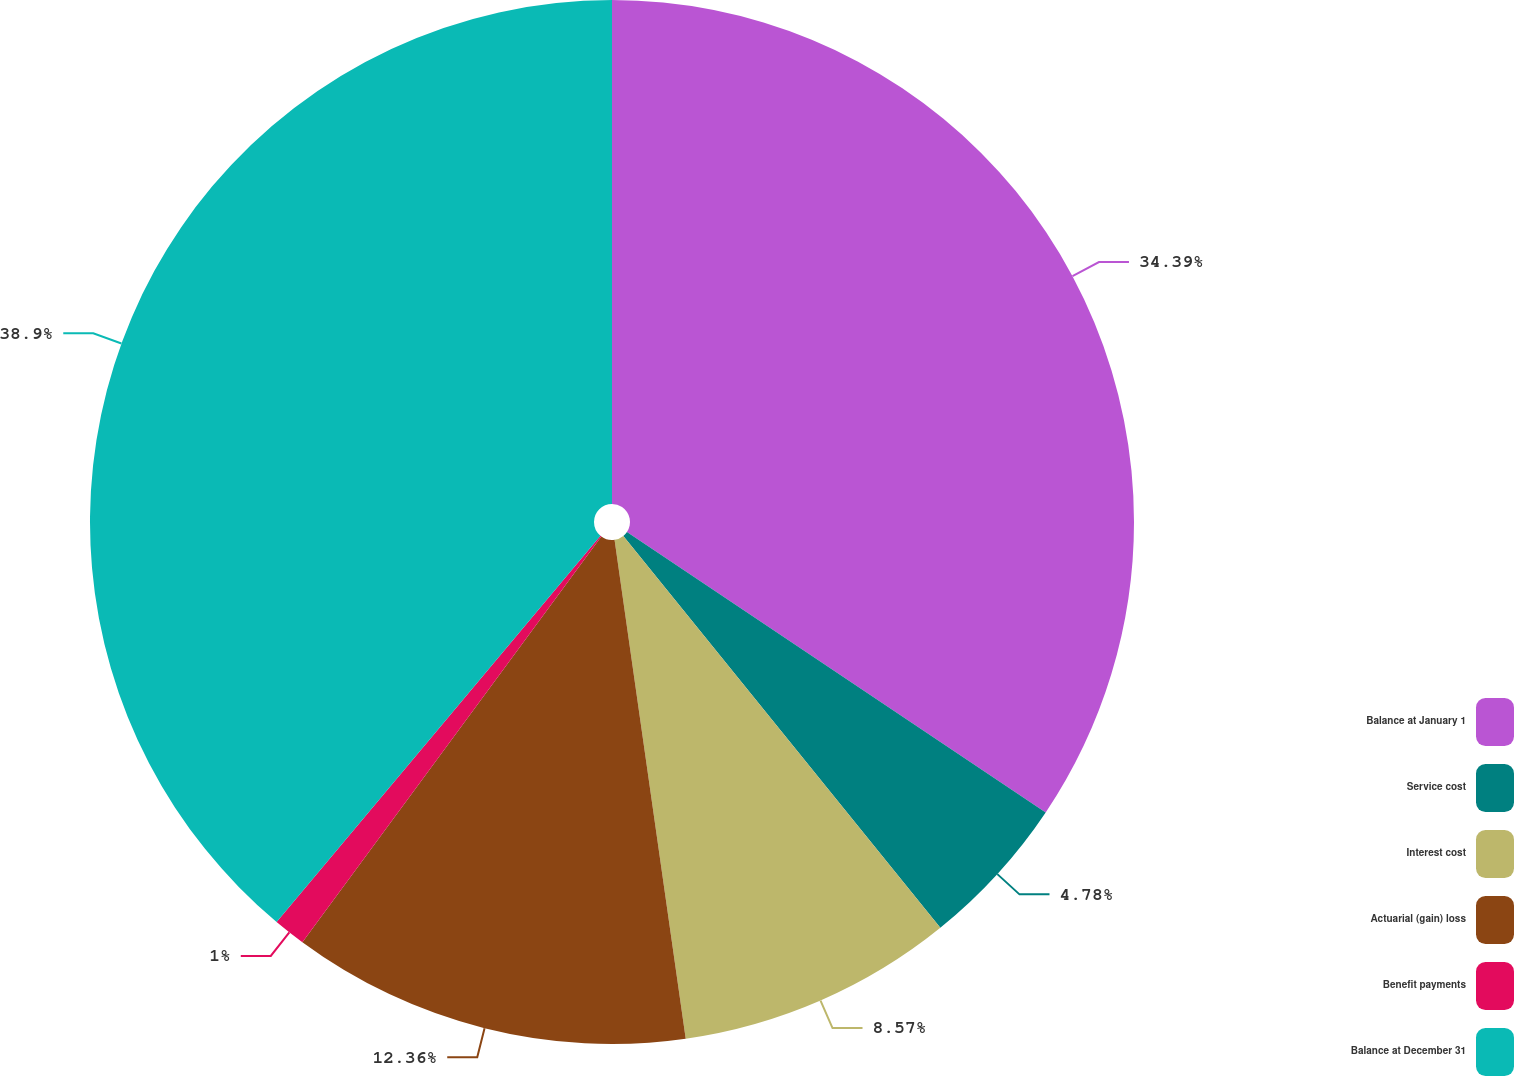<chart> <loc_0><loc_0><loc_500><loc_500><pie_chart><fcel>Balance at January 1<fcel>Service cost<fcel>Interest cost<fcel>Actuarial (gain) loss<fcel>Benefit payments<fcel>Balance at December 31<nl><fcel>34.39%<fcel>4.78%<fcel>8.57%<fcel>12.36%<fcel>1.0%<fcel>38.89%<nl></chart> 